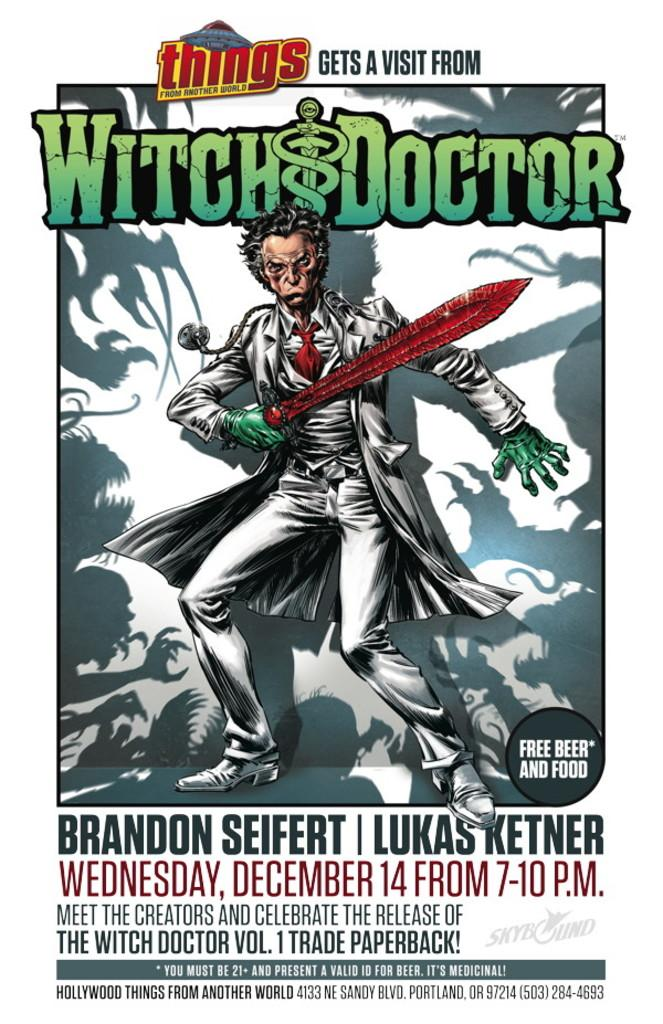Provide a one-sentence caption for the provided image. A poster advertising a paperback for the Witch Doctor. 